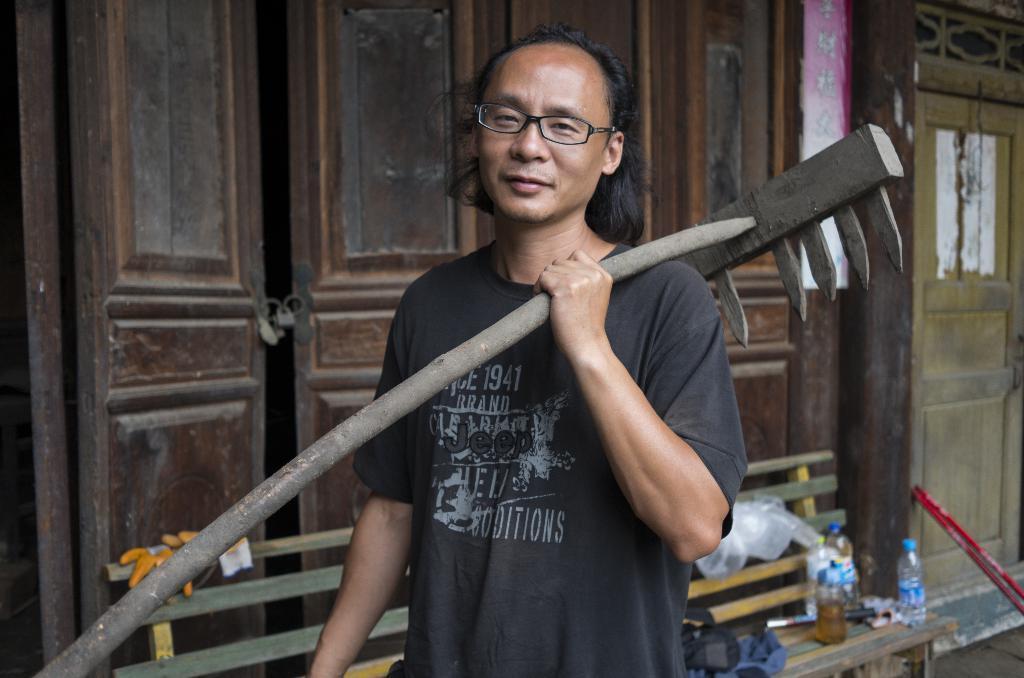Can you describe this image briefly? Here we can see a man holding a tool and he has spectacles. In the background we can see a door, bench, and bottles. 